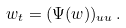Convert formula to latex. <formula><loc_0><loc_0><loc_500><loc_500>w _ { t } = ( \Psi ( w ) ) _ { u u } \, .</formula> 